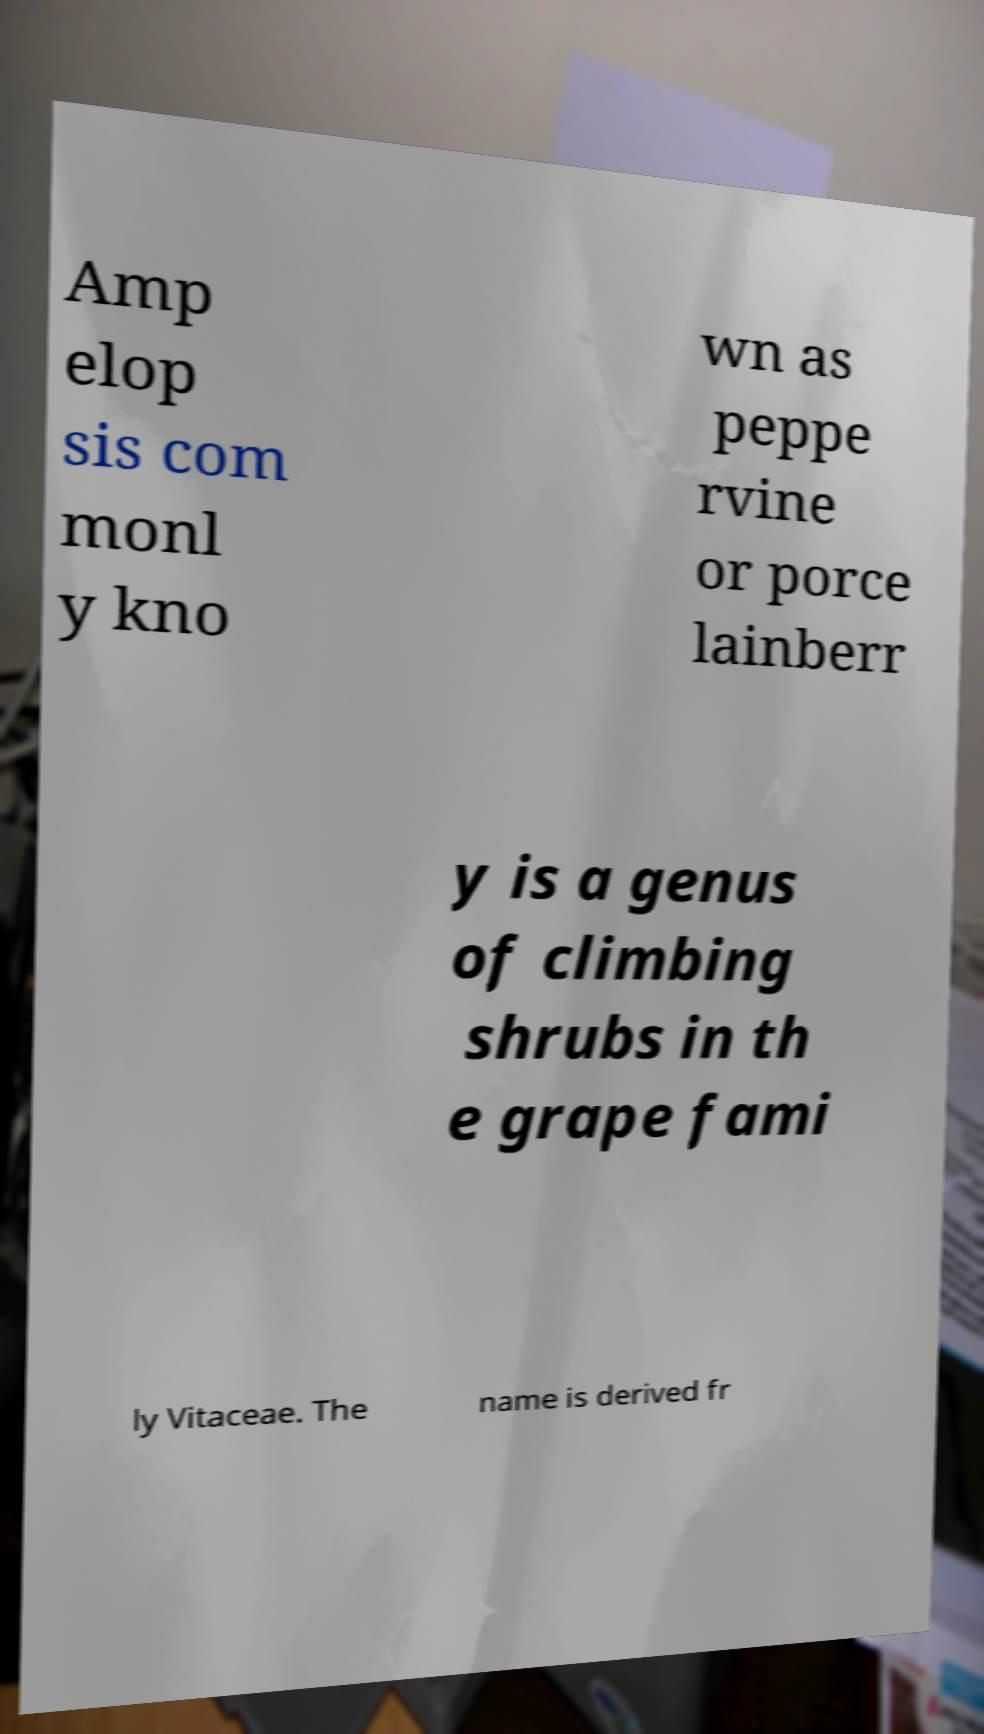I need the written content from this picture converted into text. Can you do that? Amp elop sis com monl y kno wn as peppe rvine or porce lainberr y is a genus of climbing shrubs in th e grape fami ly Vitaceae. The name is derived fr 